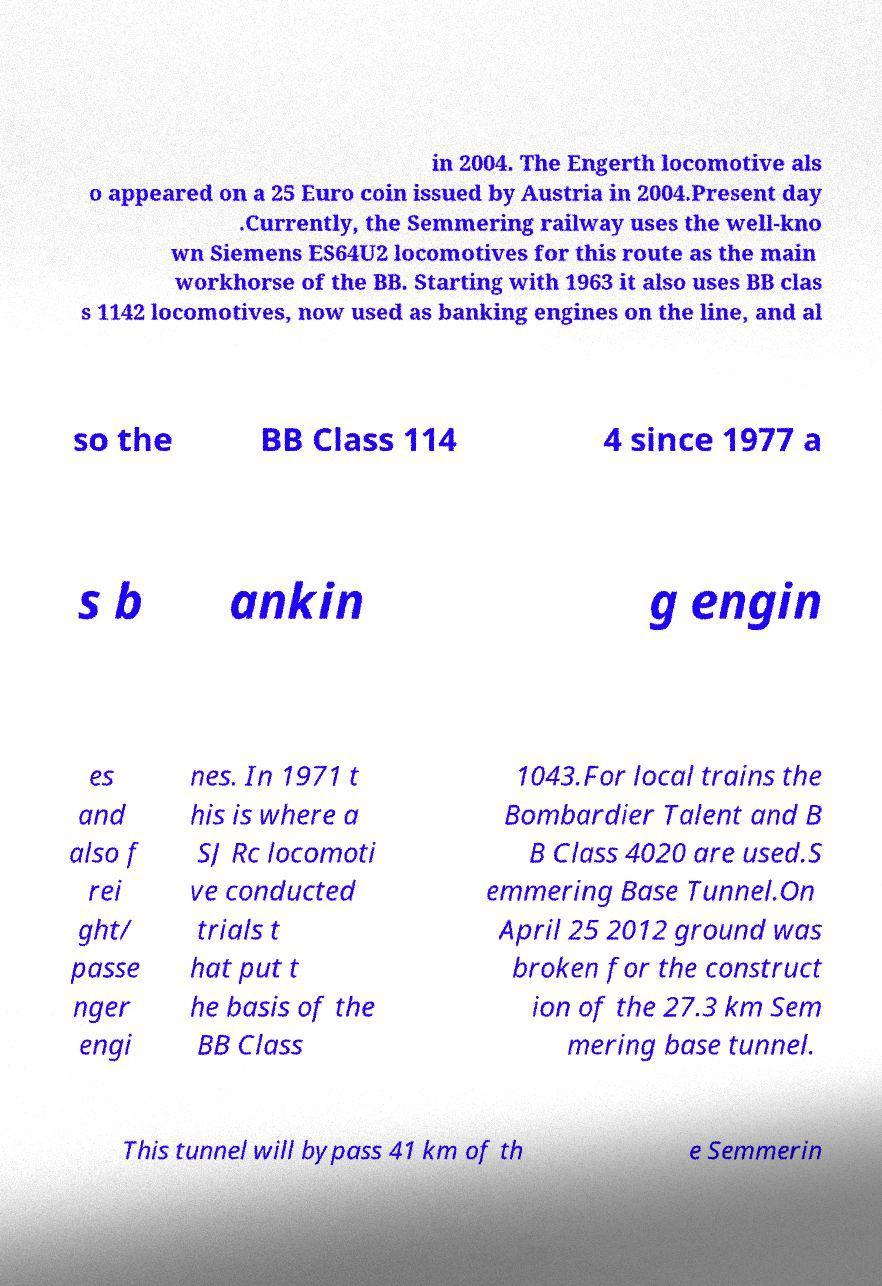For documentation purposes, I need the text within this image transcribed. Could you provide that? in 2004. The Engerth locomotive als o appeared on a 25 Euro coin issued by Austria in 2004.Present day .Currently, the Semmering railway uses the well-kno wn Siemens ES64U2 locomotives for this route as the main workhorse of the BB. Starting with 1963 it also uses BB clas s 1142 locomotives, now used as banking engines on the line, and al so the BB Class 114 4 since 1977 a s b ankin g engin es and also f rei ght/ passe nger engi nes. In 1971 t his is where a SJ Rc locomoti ve conducted trials t hat put t he basis of the BB Class 1043.For local trains the Bombardier Talent and B B Class 4020 are used.S emmering Base Tunnel.On April 25 2012 ground was broken for the construct ion of the 27.3 km Sem mering base tunnel. This tunnel will bypass 41 km of th e Semmerin 